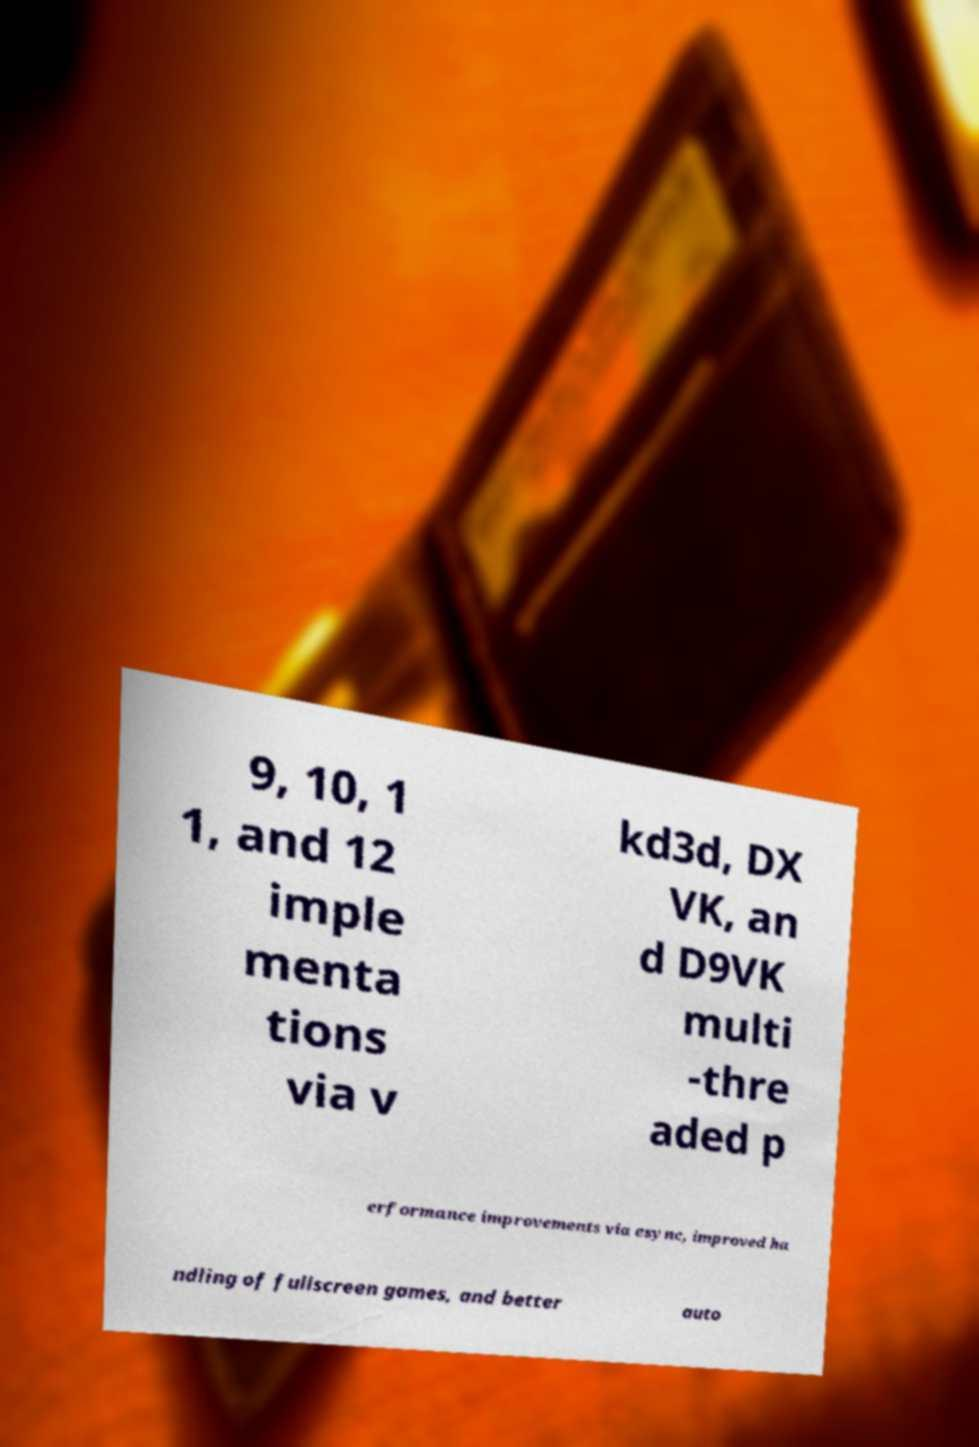Please read and relay the text visible in this image. What does it say? 9, 10, 1 1, and 12 imple menta tions via v kd3d, DX VK, an d D9VK multi -thre aded p erformance improvements via esync, improved ha ndling of fullscreen games, and better auto 